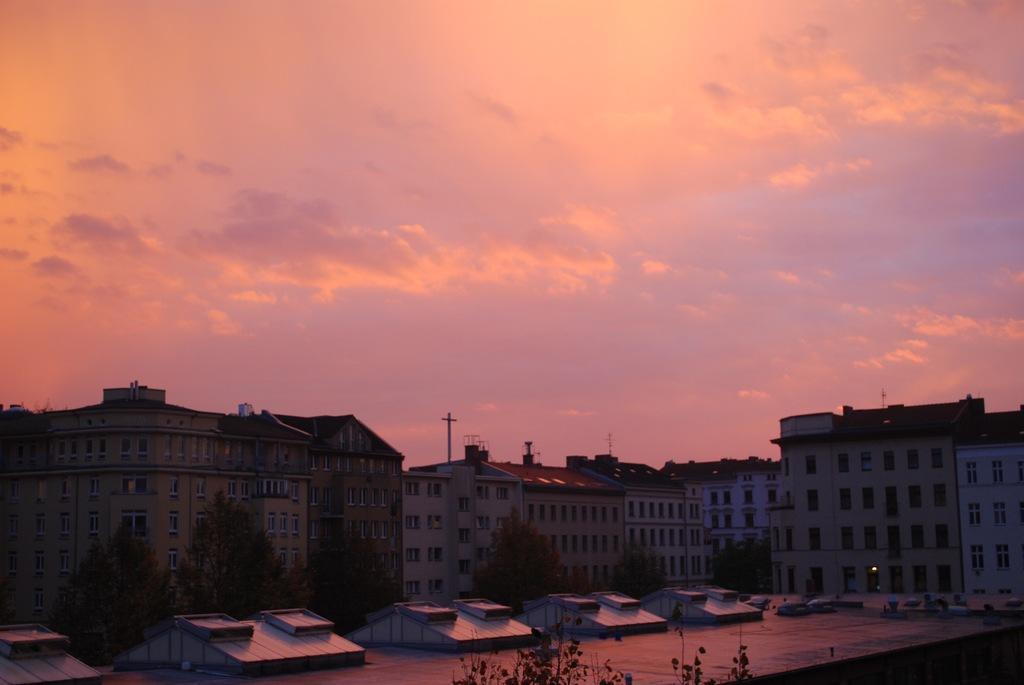In one or two sentences, can you explain what this image depicts? This image is clicked outside. There are buildings in the middle. There are trees at the bottom. There is sky at the top. 